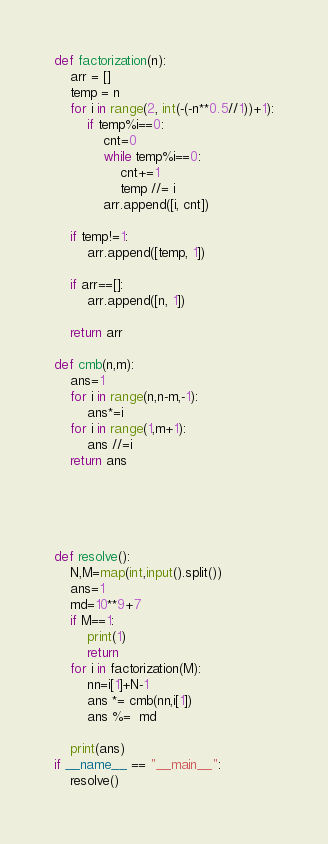<code> <loc_0><loc_0><loc_500><loc_500><_Python_>
def factorization(n):
    arr = []
    temp = n
    for i in range(2, int(-(-n**0.5//1))+1):
        if temp%i==0:
            cnt=0
            while temp%i==0:
                cnt+=1
                temp //= i
            arr.append([i, cnt])

    if temp!=1:
        arr.append([temp, 1])

    if arr==[]:
        arr.append([n, 1])

    return arr

def cmb(n,m):
    ans=1
    for i in range(n,n-m,-1):
        ans*=i
    for i in range(1,m+1):
        ans //=i
    return ans





def resolve():
    N,M=map(int,input().split())
    ans=1
    md=10**9+7
    if M==1:
        print(1)
        return
    for i in factorization(M):
        nn=i[1]+N-1
        ans *= cmb(nn,i[1])
        ans %=  md

    print(ans)
if __name__ == "__main__":
    resolve()</code> 